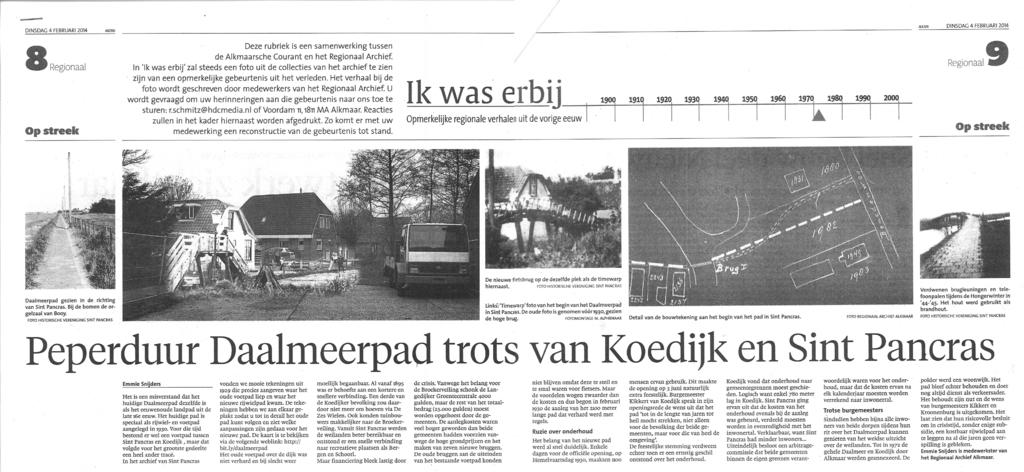What is the main object in the image? There is a newspaper in the image. What type of content can be found in the newspaper? The newspaper contains text and images. What type of destruction can be seen in the downtown area in the image? There is no downtown area or destruction present in the image; it only features a newspaper with text and images. 